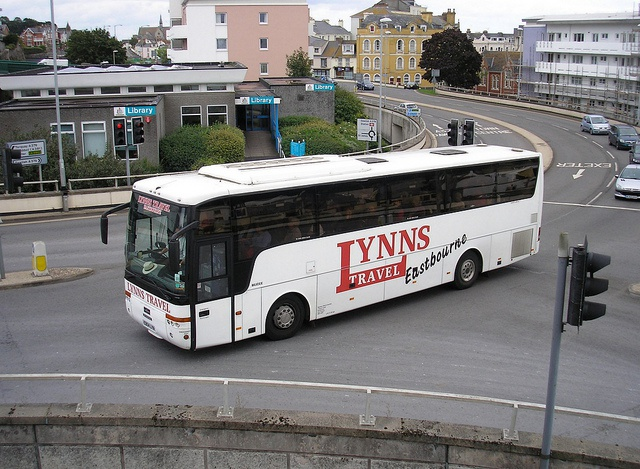Describe the objects in this image and their specific colors. I can see bus in lavender, lightgray, black, gray, and darkgray tones, traffic light in lavender, black, and gray tones, car in lavender, black, and gray tones, traffic light in lavender, black, gray, and darkgray tones, and car in lavender, black, gray, and darkgray tones in this image. 